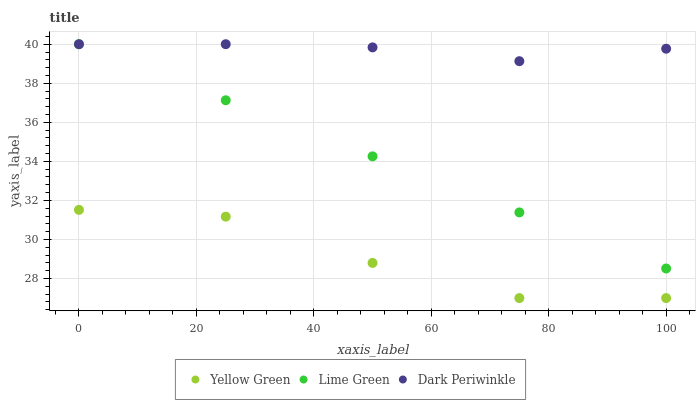Does Yellow Green have the minimum area under the curve?
Answer yes or no. Yes. Does Dark Periwinkle have the maximum area under the curve?
Answer yes or no. Yes. Does Dark Periwinkle have the minimum area under the curve?
Answer yes or no. No. Does Yellow Green have the maximum area under the curve?
Answer yes or no. No. Is Lime Green the smoothest?
Answer yes or no. Yes. Is Yellow Green the roughest?
Answer yes or no. Yes. Is Dark Periwinkle the smoothest?
Answer yes or no. No. Is Dark Periwinkle the roughest?
Answer yes or no. No. Does Yellow Green have the lowest value?
Answer yes or no. Yes. Does Dark Periwinkle have the lowest value?
Answer yes or no. No. Does Dark Periwinkle have the highest value?
Answer yes or no. Yes. Does Yellow Green have the highest value?
Answer yes or no. No. Is Yellow Green less than Dark Periwinkle?
Answer yes or no. Yes. Is Lime Green greater than Yellow Green?
Answer yes or no. Yes. Does Dark Periwinkle intersect Lime Green?
Answer yes or no. Yes. Is Dark Periwinkle less than Lime Green?
Answer yes or no. No. Is Dark Periwinkle greater than Lime Green?
Answer yes or no. No. Does Yellow Green intersect Dark Periwinkle?
Answer yes or no. No. 